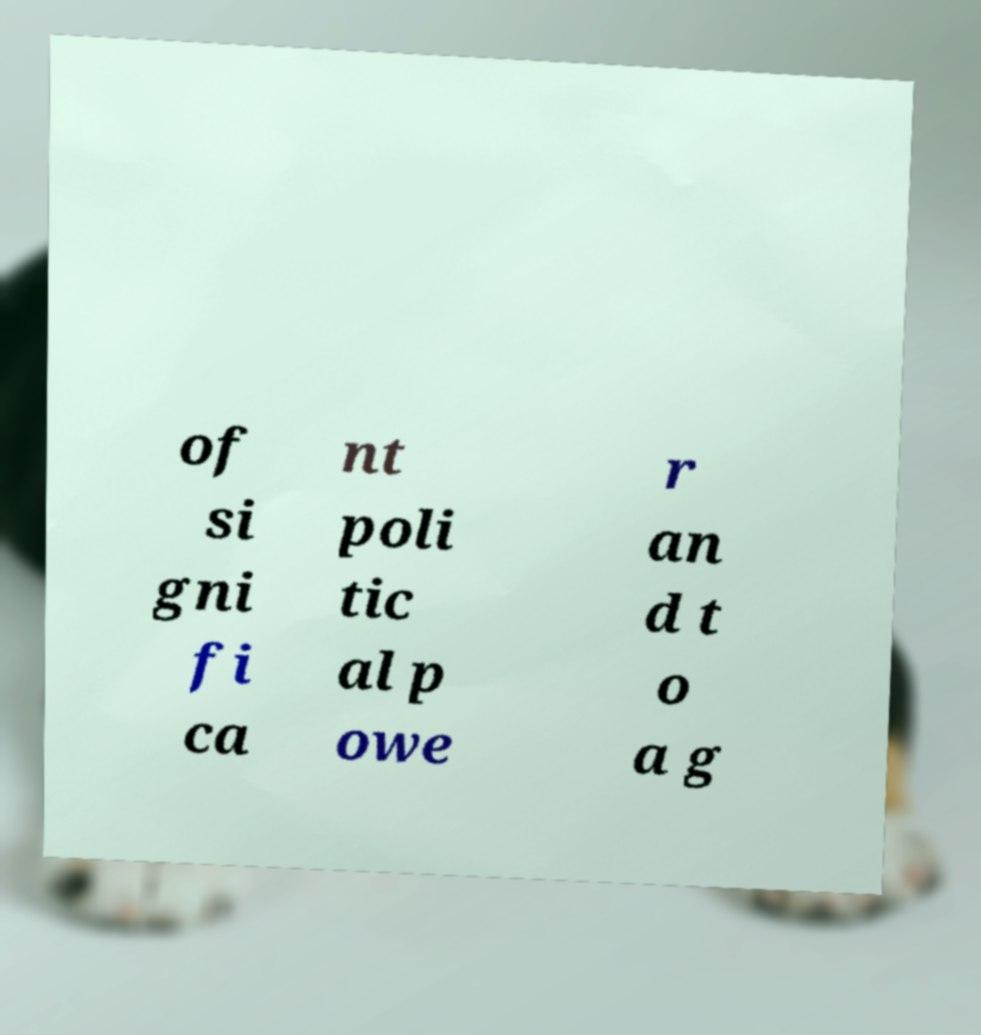Could you assist in decoding the text presented in this image and type it out clearly? of si gni fi ca nt poli tic al p owe r an d t o a g 